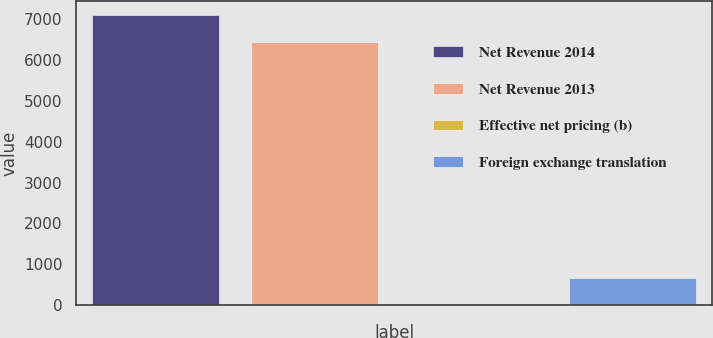<chart> <loc_0><loc_0><loc_500><loc_500><bar_chart><fcel>Net Revenue 2014<fcel>Net Revenue 2013<fcel>Effective net pricing (b)<fcel>Foreign exchange translation<nl><fcel>7092.7<fcel>6431<fcel>1<fcel>662.7<nl></chart> 